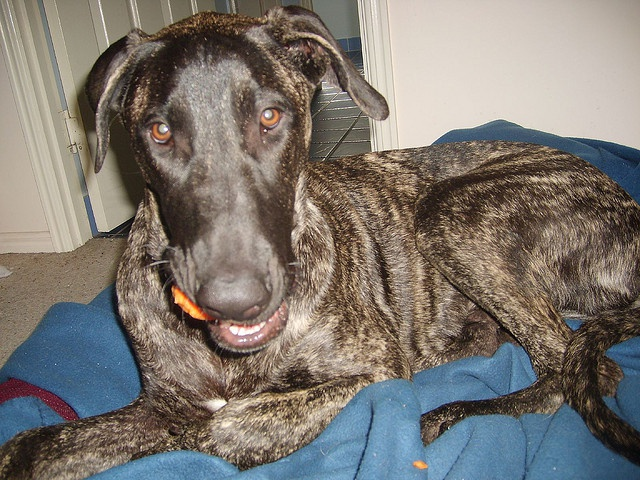Describe the objects in this image and their specific colors. I can see dog in gray, black, and darkgray tones and sports ball in gray, orange, maroon, gold, and red tones in this image. 